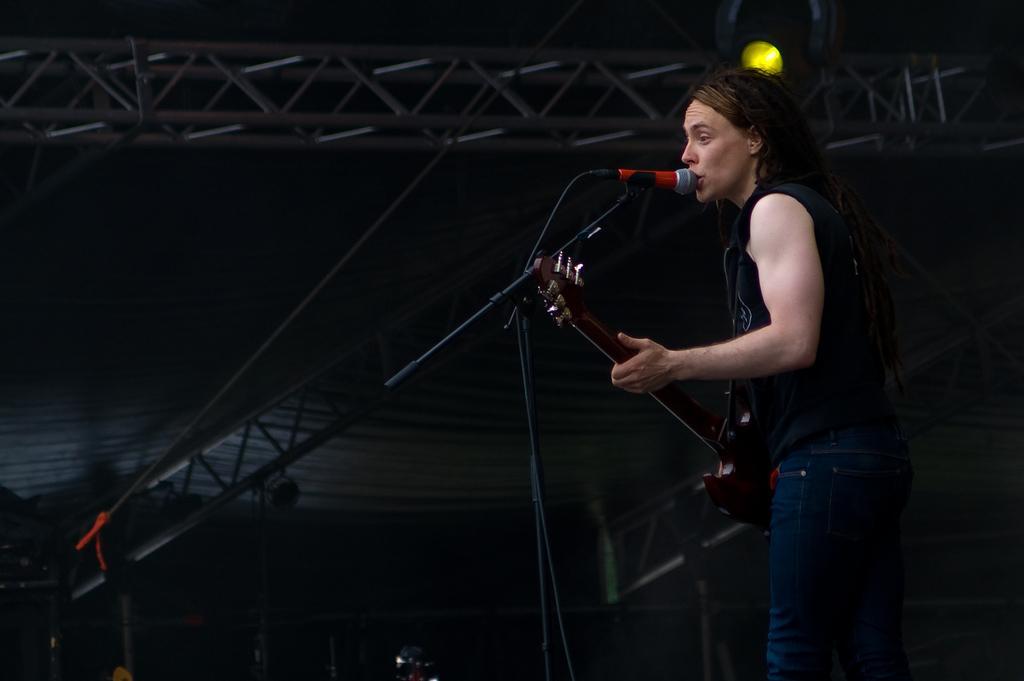Can you describe this image briefly? This picture shows a woman singing in front of a microphone and a stand, holding the guitar in her hands. In the background there is a light. 